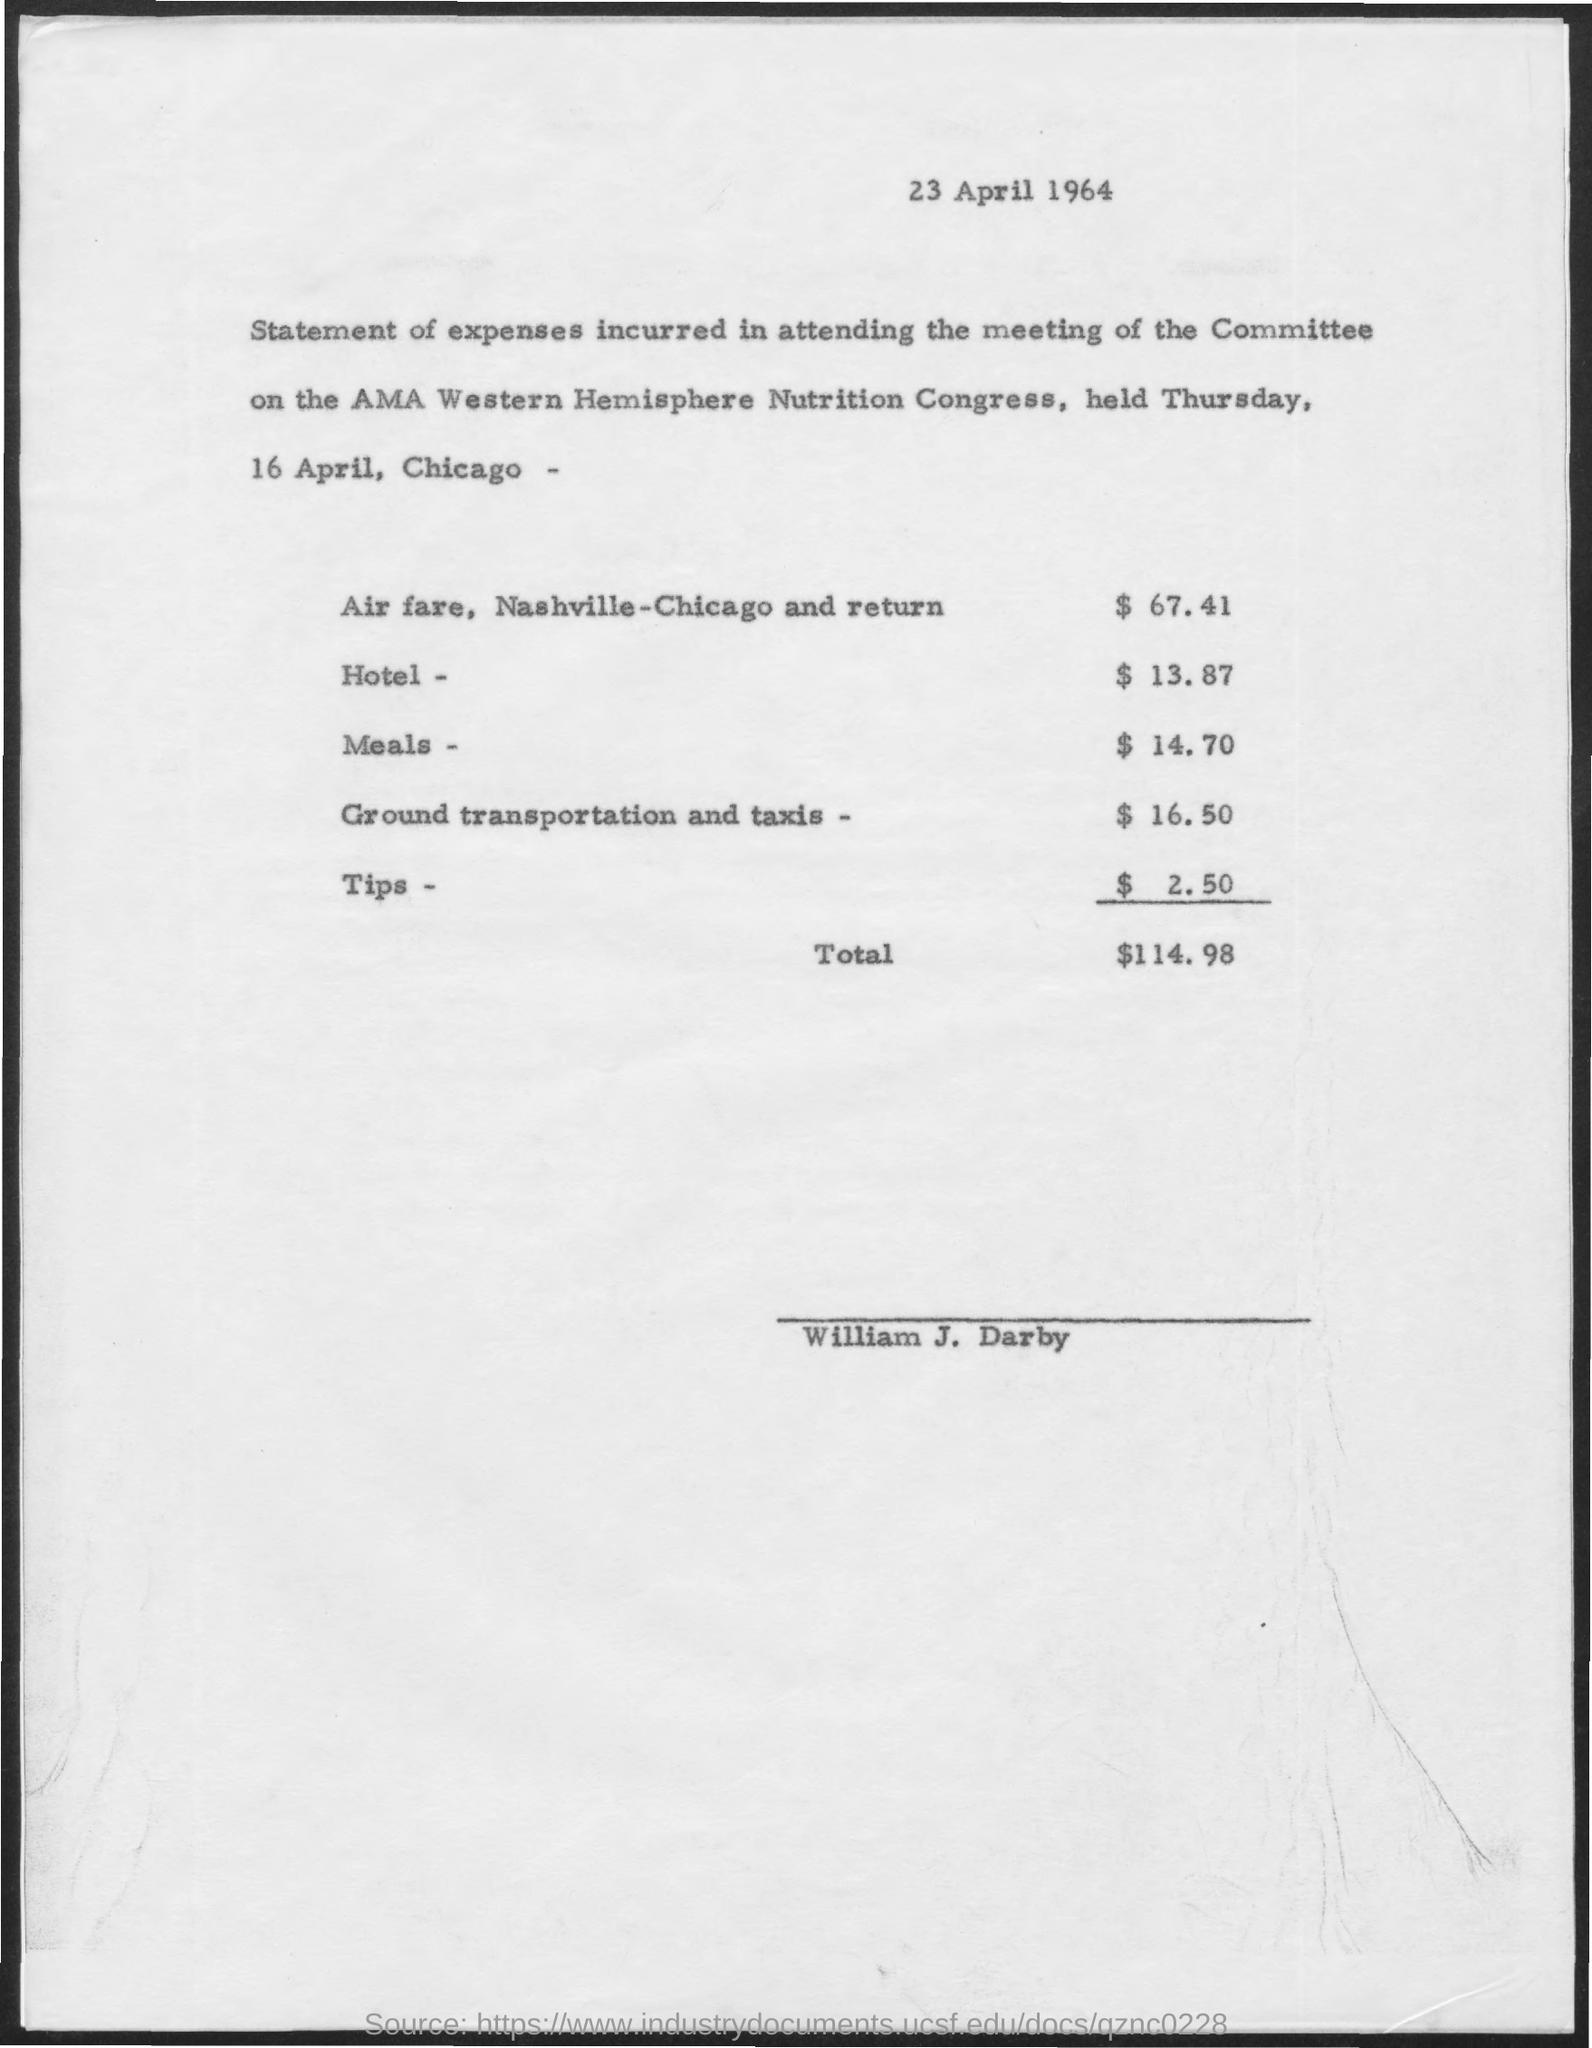Highlight a few significant elements in this photo. The person mentioned in the document is named William J. Darby. The cost of meals is $14.70. The total amount is $114.98. The document at the top contains information about a date, specifically that it is 23 April 1964. 